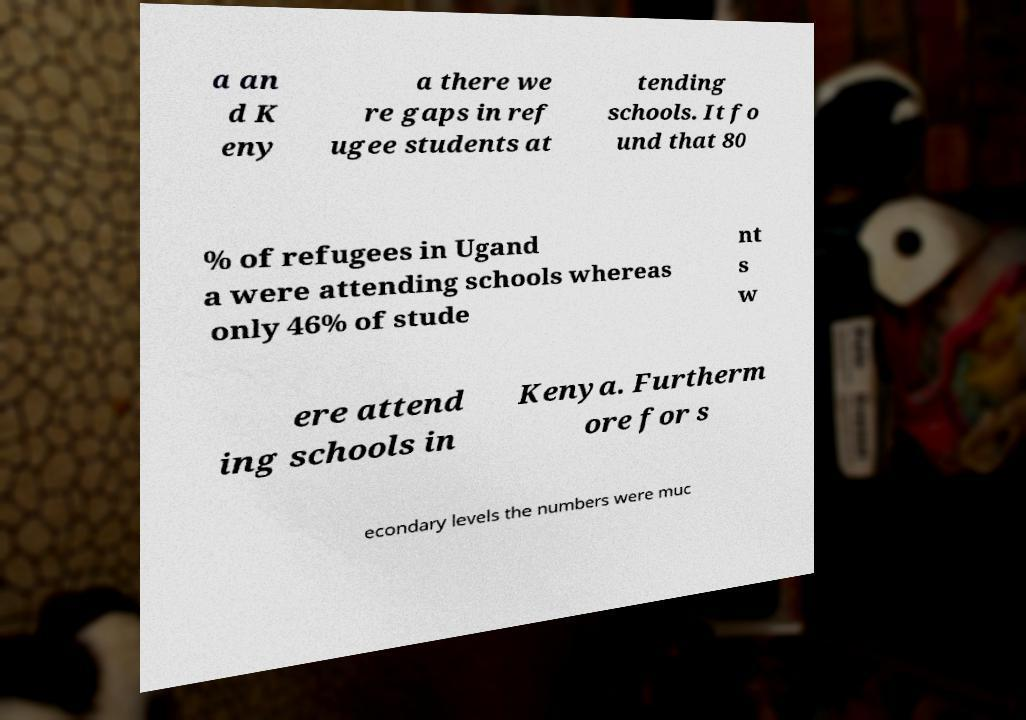I need the written content from this picture converted into text. Can you do that? a an d K eny a there we re gaps in ref ugee students at tending schools. It fo und that 80 % of refugees in Ugand a were attending schools whereas only 46% of stude nt s w ere attend ing schools in Kenya. Furtherm ore for s econdary levels the numbers were muc 